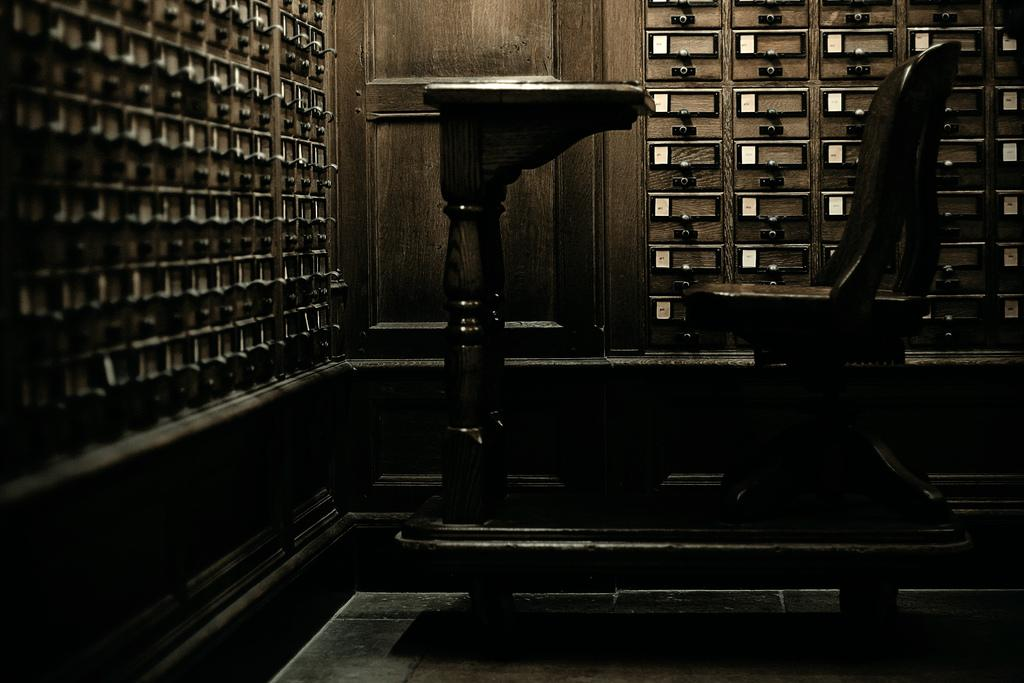What type of furniture is present in the image? There is a chair in the image. What other objects can be seen in the image? There are drawers in the image. Can you describe the lighting in the image? The image appears to be slightly dark. What type of apparatus is being used for writing in the image? There is no apparatus for writing present in the image. Can you see a stick in the image? There is no stick visible in the image. 